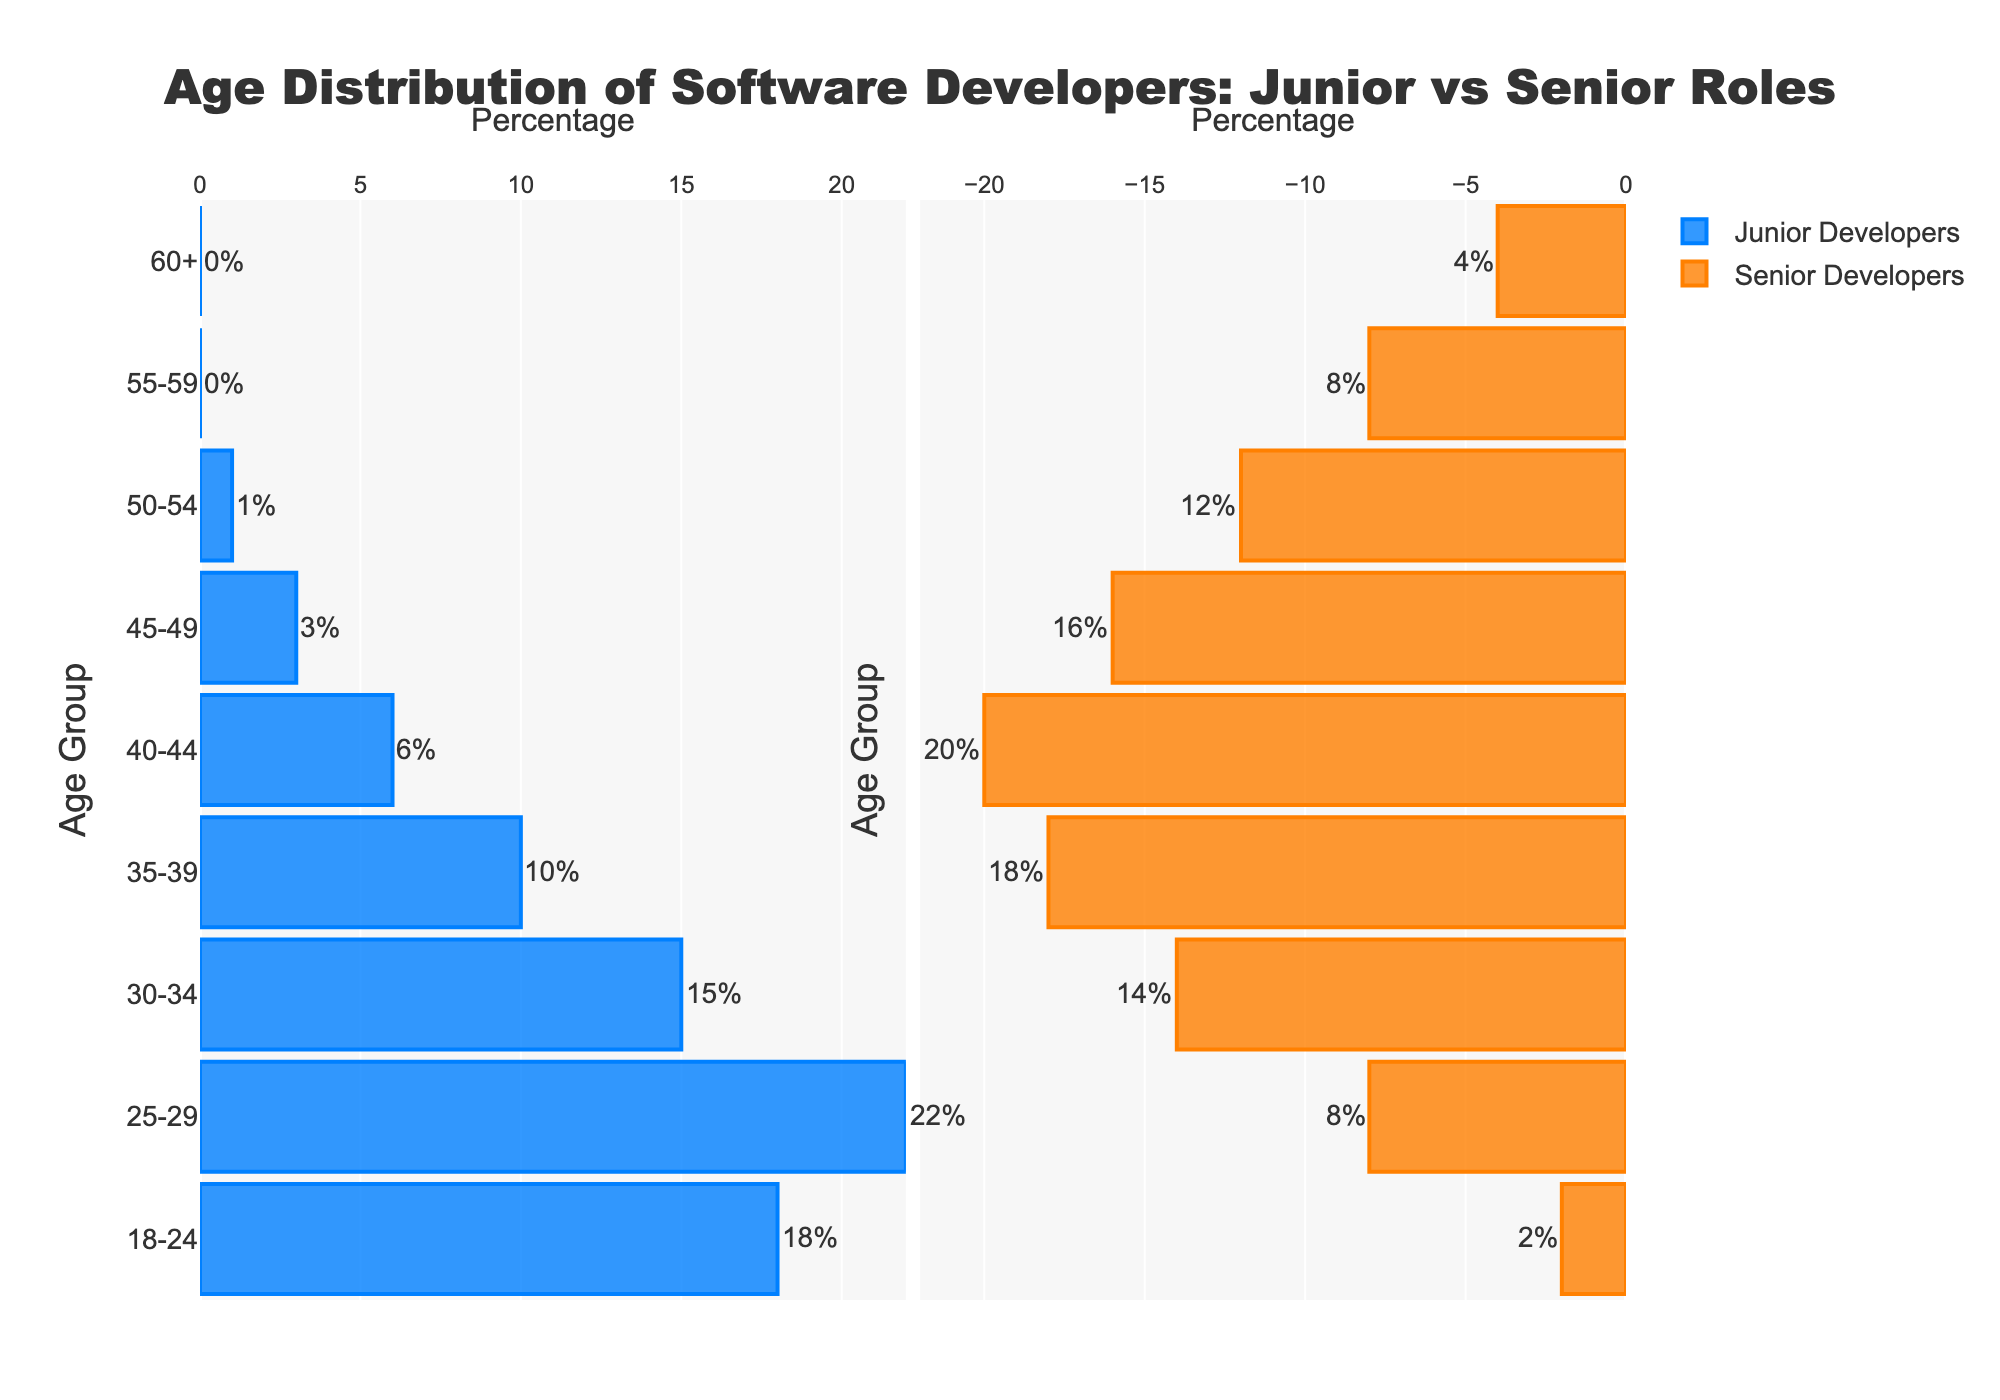what is the title of the figure? The title is located at the top center of the figure. It reads, "Age Distribution of Software Developers: Junior vs Senior Roles."
Answer: Age Distribution of Software Developers: Junior vs Senior Roles Which age group has the largest percentage of junior developers? By examining the lengths of the blue bars on the left side, 25-29 is the longest, indicating it has the largest percentage of junior developers.
Answer: 25-29 In which two age groups do senior developers outnumber junior developers the most? By comparing the lengths of the orange bars on the right side against the blue bars on the left, the 40-44 and 35-39 age groups show the largest discrepancy, with senior bars being significantly longer.
Answer: 40-44 and 35-39 How many age groups have more junior developers than senior developers? By counting age groups where the blue bars are longer than the orange bars, we see the 18-24 and 25-29 age groups fit this criteria.
Answer: 2 What is the difference in the percentage of developers in the age group 30-34 between junior and senior roles? For the 30-34 age group, the blue bar indicates 15%, and the negative orange bar indicates 14%. The difference is \( 15\% - 14\% \).
Answer: 1% What might the age pyramid suggest about the experience level distribution among software developers? The figure shows more juniors in younger age groups and more seniors in older age groups. This suggests that as developers age, they tend to move into senior roles.
Answer: Developers move into senior roles as they age Are there any age groups where no junior developers are reported? By examining the junior bars, we see that there are no junior developers reported in the 55-59 and 60+ age groups.
Answer: 55-59 and 60+ What is the total percentage of developers aged 45+ who are seniors? By summing the percentages of senior developers in the 45-49, 50-54, 55-59, and 60+ age groups: \( 16\% + 12\% + 8\% + 4\% = 40\% \).
Answer: 40% In terms of the age distribution, how does the 25-29 group of junior developers compare numerically to the 50-54 group of senior developers? The 25-29 group of juniors has 22%, while the 50-54 group of seniors has 12%. There are 10% more juniors in 25-29 than seniors in 50-54.
Answer: 10% more juniors Which age group shows the closest percentage between junior and senior developers? By comparing the gene-age percentage values, the 30-34 age group is closest with a 1% difference between juniors (15%) and seniors (14%).
Answer: 30-34 